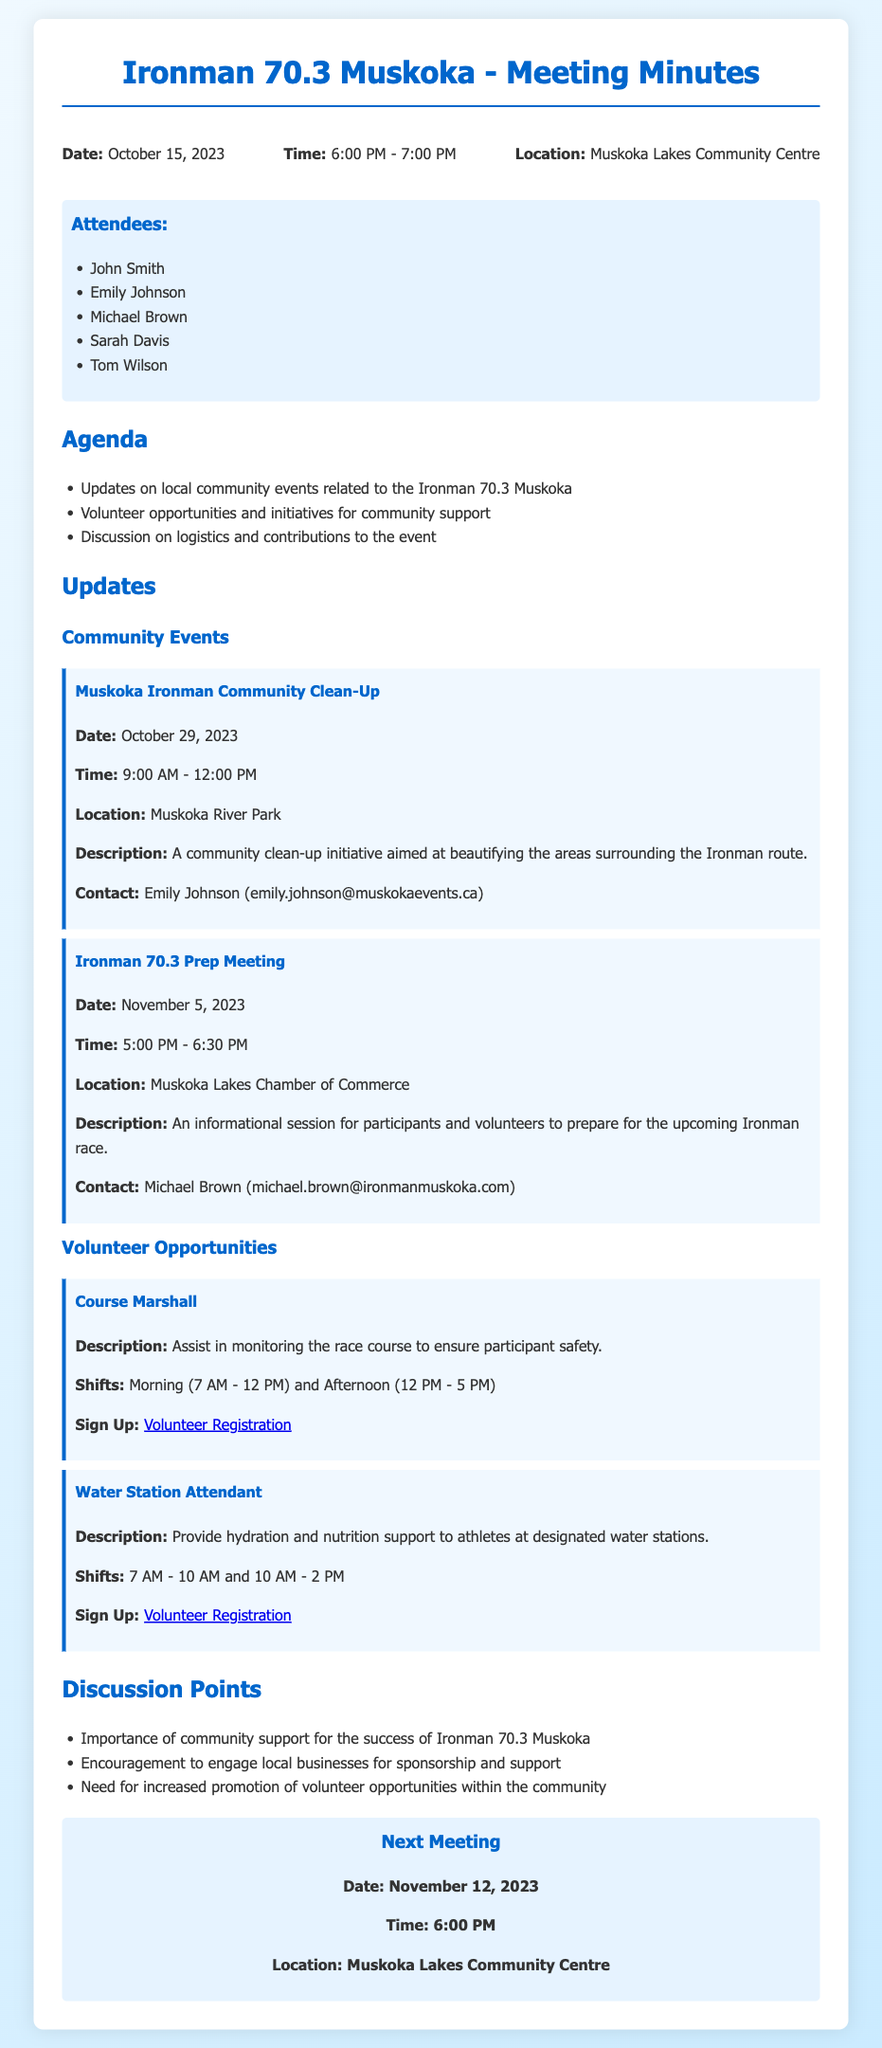what is the date of the community clean-up event? The community clean-up event date is mentioned in the updates section of the document.
Answer: October 29, 2023 who can be contacted about the Ironman 70.3 prep meeting? The document specifies a contact person for the Ironman 70.3 prep meeting under the event details.
Answer: Michael Brown what is the location of the next meeting? The next meeting location is stated in the document's next meeting section.
Answer: Muskoka Lakes Community Centre how many shifts are available for the water station attendant position? The number of shifts can be deduced from the specified times given for the water station attendant position in the volunteer opportunities section.
Answer: Two shifts what is the importance of community support mentioned in the discussion points? The document emphasizes the critical role of community support for the event's success, located in the discussion points section.
Answer: Success of Ironman 70.3 Muskoka what time does the Ironman 70.3 Prep Meeting start? The start time of the Ironman 70.3 Prep Meeting is provided in the updates section under the event details.
Answer: 5:00 PM how is volunteer engagement suggested to be increased? The document discusses the need for promoting volunteer opportunities as a way to improve engagement in the community.
Answer: Increased promotion which two volunteer positions are outlined in the document? The document specifies volunteer positions in the updates section, providing titles for each.
Answer: Course Marshall and Water Station Attendant 